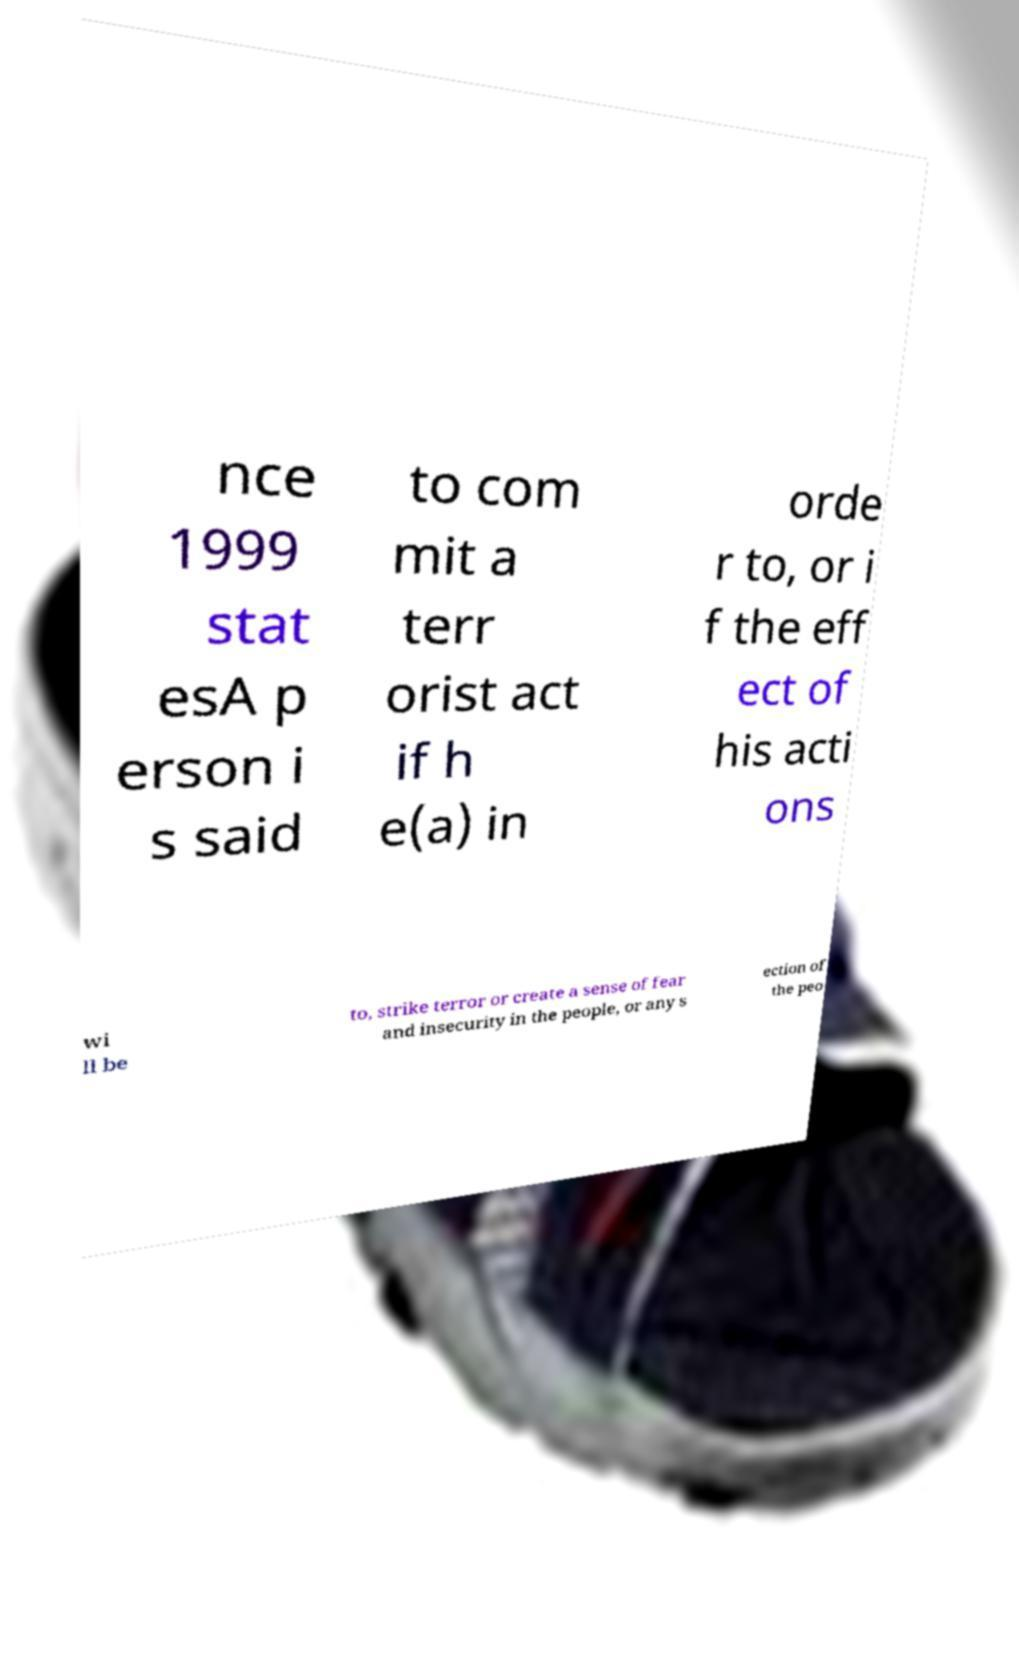What messages or text are displayed in this image? I need them in a readable, typed format. nce 1999 stat esA p erson i s said to com mit a terr orist act if h e(a) in orde r to, or i f the eff ect of his acti ons wi ll be to, strike terror or create a sense of fear and insecurity in the people, or any s ection of the peo 